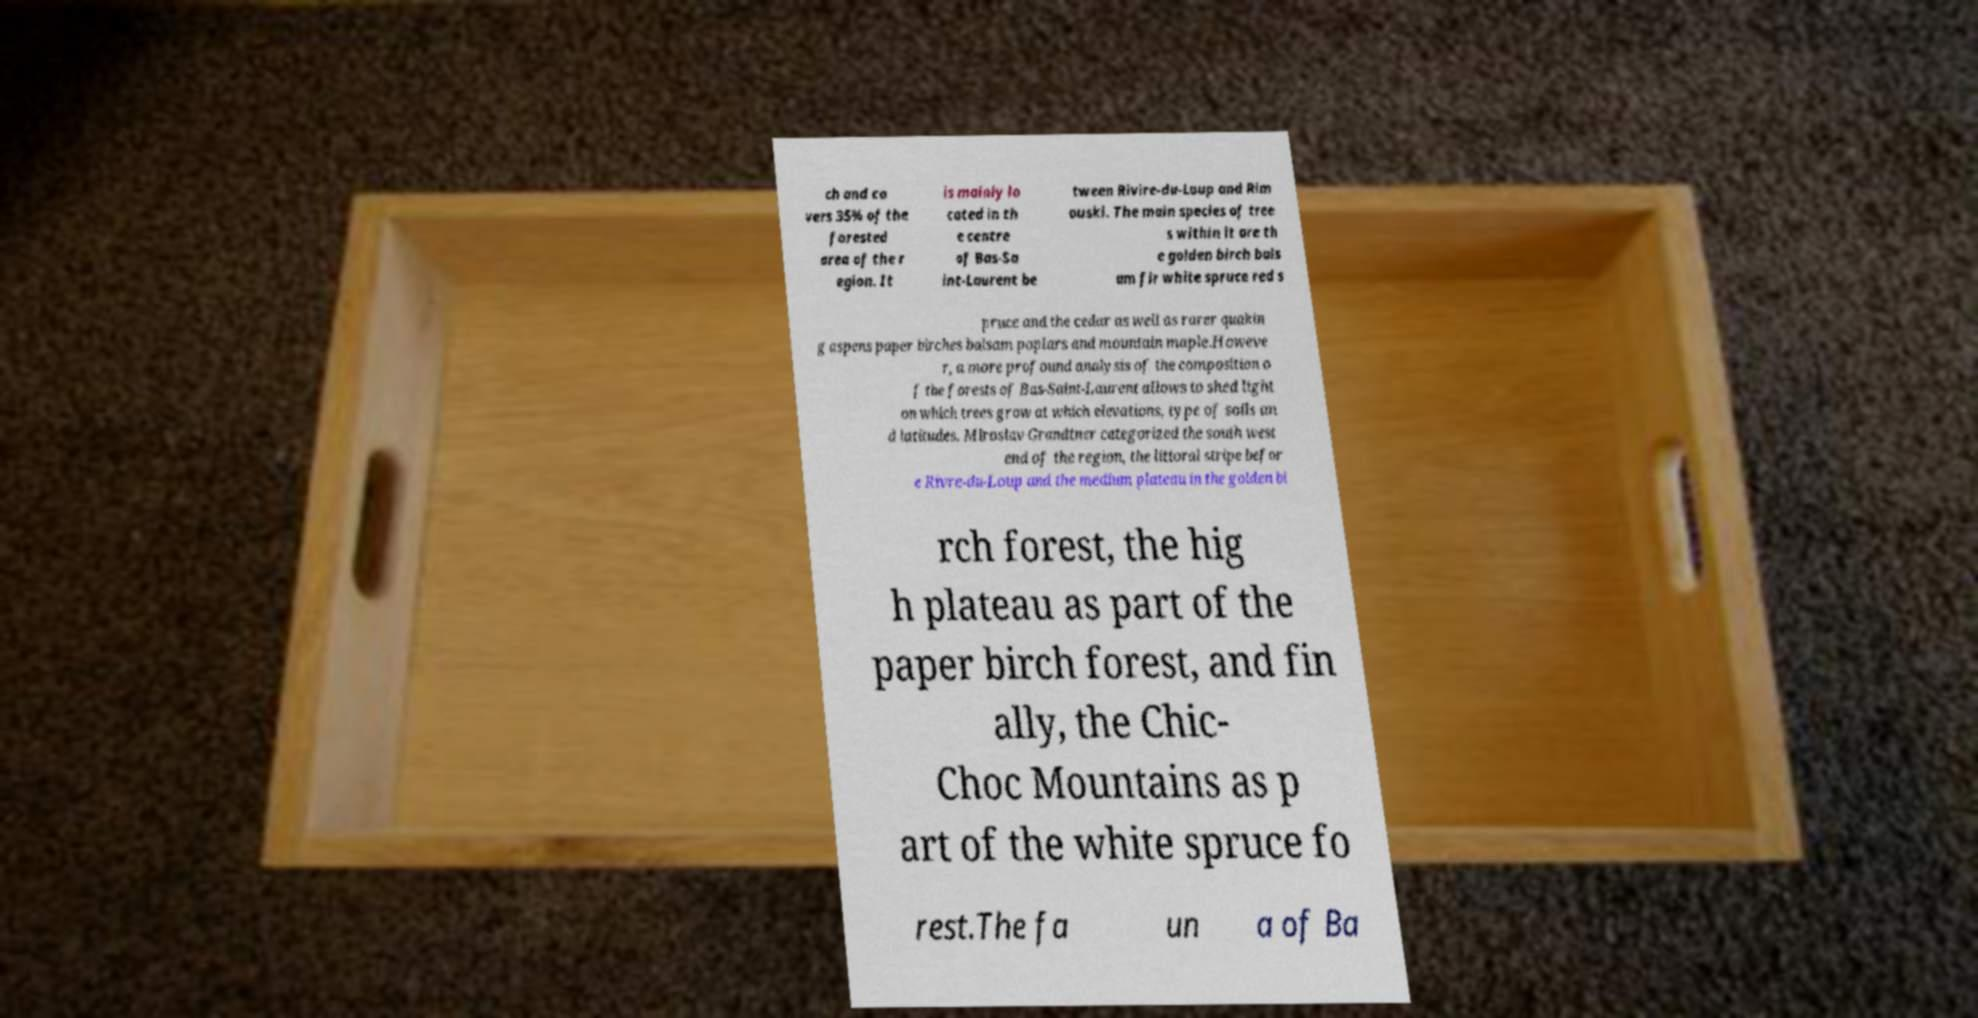Could you extract and type out the text from this image? ch and co vers 35% of the forested area of the r egion. It is mainly lo cated in th e centre of Bas-Sa int-Laurent be tween Rivire-du-Loup and Rim ouski. The main species of tree s within it are th e golden birch bals am fir white spruce red s pruce and the cedar as well as rarer quakin g aspens paper birches balsam poplars and mountain maple.Howeve r, a more profound analysis of the composition o f the forests of Bas-Saint-Laurent allows to shed light on which trees grow at which elevations, type of soils an d latitudes. Miroslav Grandtner categorized the south west end of the region, the littoral stripe befor e Rivre-du-Loup and the medium plateau in the golden bi rch forest, the hig h plateau as part of the paper birch forest, and fin ally, the Chic- Choc Mountains as p art of the white spruce fo rest.The fa un a of Ba 